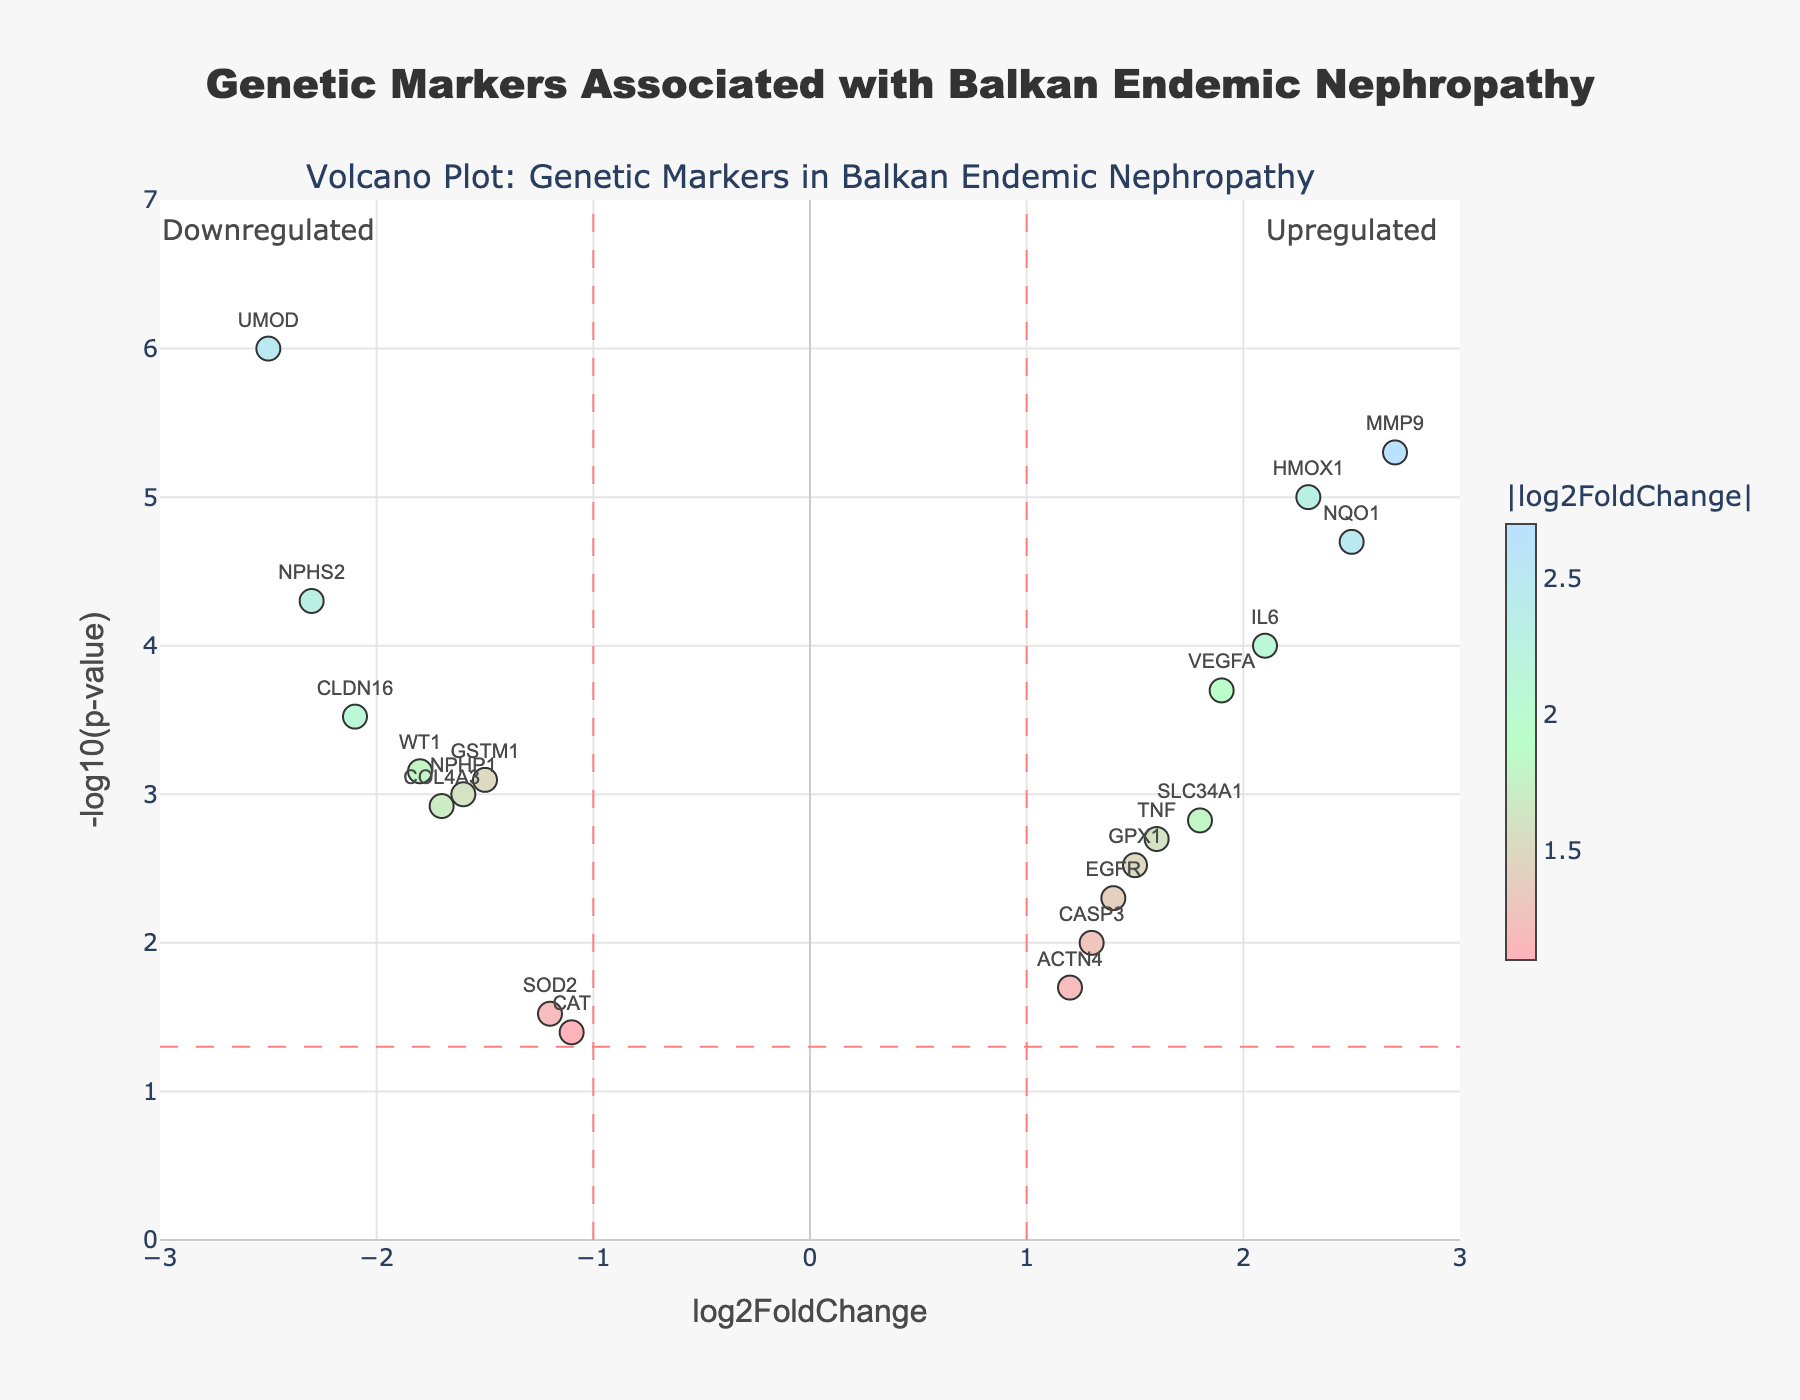What is the title of the plot? The title of the figure is the main text at the top of the plot. It reads "Genetic Markers Associated with Balkan Endemic Nephropathy."
Answer: Genetic Markers Associated with Balkan Endemic Nephropathy Which gene has the highest log2FoldChange? To determine the gene with the highest log2FoldChange, look at the farthest rightmost point on the x-axis. The gene at this position is MMP9 with a log2FoldChange of 2.7.
Answer: MMP9 Which gene has the smallest p-value? The smallest p-value will be represented by the highest point on the y-axis. The gene at this position is UMOD with a -log10(p-value) of approximately 6.
Answer: UMOD How many genes have a log2FoldChange greater than 2? Identify the points on the plot that are located to the right of the vertical line at log2FoldChange = 2. The genes meeting this criterion are HMOX1, MMP9, and NQO1, totaling 3 genes.
Answer: 3 Which genes are downregulated with a log2FoldChange less than -2? Downregulated genes are located to the left of the vertical line at log2FoldChange = -2. The genes in this region are CLDN16, NPHS2, and UMOD.
Answer: CLDN16, NPHS2, UMOD Which gene appears at the intersection of the vertical and horizontal lines indicating thresholds? The vertical lines are at log2FoldChange = -1 and 1, and the horizontal line is at -log10(p-value) = 1.3. The gene near this intersection is GPX1 with a log2FoldChange of 1.5 and a -log10(p-value) around 2.5.
Answer: GPX1 Which genes are both upregulated and significantly altered (p-value < 0.05)? Upregulated genes have log2FoldChange > 1, and significantly altered genes have -log10(p-value) > 1.3. The genes meeting these criteria are SLC34A1, HMOX1, VEGFA, MMP9, IL6, NQO1, TNF, GPX1, ACTN4.
Answer: SLC34A1, HMOX1, VEGFA, MMP9, IL6, NQO1, TNF, GPX1, ACTN4 How many genes have a p-value less than 0.01? Identify the points higher than around -log10(p-value) = 2 on the y-axis. These genes are CLDN16, SLC34A1, HMOX1, GSTM1, VEGFA, MMP9, COL4A3, IL6, TNF, NQO1, NPHS2, WT1, UMOD, NPHP1, summing up to 14 genes.
Answer: 14 